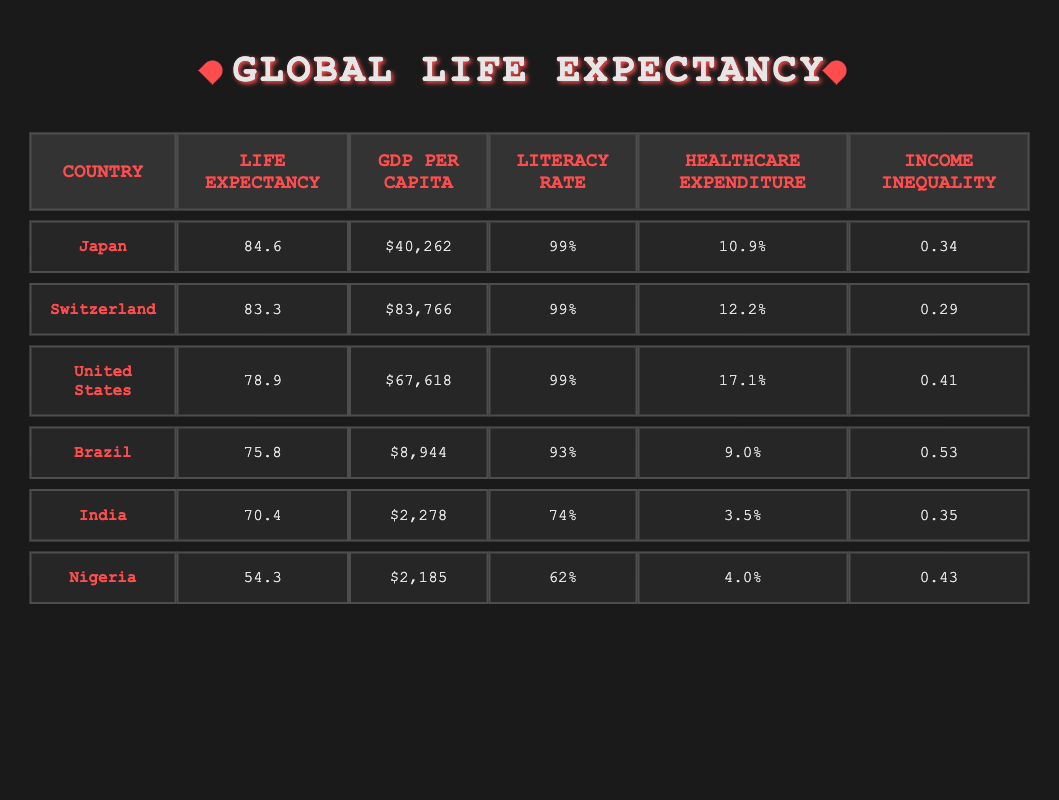What is the highest life expectancy among the countries listed? Japan has the highest life expectancy at 84.6 years, as shown in the Life Expectancy column of the table.
Answer: 84.6 Which country has the lowest GDP per capita? Nigeria has the lowest GDP per capita at $2,185, as visible in the GDP Per Capita column of the table.
Answer: $2,185 Is the literacy rate in Brazil greater than 90 percent? Yes, Brazil has a literacy rate of 93%, which is greater than 90%.
Answer: Yes What is the difference in life expectancy between Switzerland and India? Switzerland's life expectancy is 83.3 years and India's is 70.4 years. The difference is calculated as 83.3 - 70.4 = 12.9 years.
Answer: 12.9 Which country has the highest healthcare expenditure percentage? The United States has the highest healthcare expenditure at 17.1%, as stated in the Healthcare Expenditure column.
Answer: 17.1% If we average the life expectancy of Japan, Switzerland, and the United States, what do we get? The life expectancy values for Japan, Switzerland, and the United States are 84.6, 83.3, and 78.9 respectively. The average is calculated as (84.6 + 83.3 + 78.9) / 3 = 82.3 years.
Answer: 82.3 Is the income inequality in Brazil lower than in Nigeria? No, Brazil has an income inequality of 0.53, which is higher than Nigeria's 0.43, meaning Brazil's inequality is greater.
Answer: No How does the healthcare expenditure of Brazil compare to that of Japan? Brazil has a healthcare expenditure of 9.0% while Japan's is 10.9%. Japan's expenditure is greater.
Answer: Japan's is greater What is the overall trend between GDP per capita and life expectancy based on this table? Higher GDP per capita generally corresponds to higher life expectancy, as seen with Japan and Switzerland, compared to lower GDP and life expectancy in Nigeria and India.
Answer: Higher GDP leads to higher life expectancy 